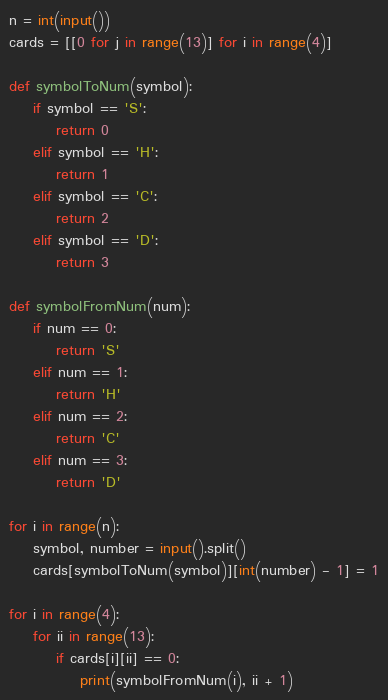<code> <loc_0><loc_0><loc_500><loc_500><_Python_>n = int(input())
cards = [[0 for j in range(13)] for i in range(4)]

def symbolToNum(symbol):
    if symbol == 'S':
        return 0
    elif symbol == 'H':
        return 1
    elif symbol == 'C':
        return 2
    elif symbol == 'D':
        return 3

def symbolFromNum(num):
    if num == 0:
        return 'S'
    elif num == 1:
        return 'H'
    elif num == 2:
        return 'C'
    elif num == 3:
        return 'D'

for i in range(n):
    symbol, number = input().split()
    cards[symbolToNum(symbol)][int(number) - 1] = 1

for i in range(4):
    for ii in range(13):
        if cards[i][ii] == 0:
            print(symbolFromNum(i), ii + 1)

</code> 